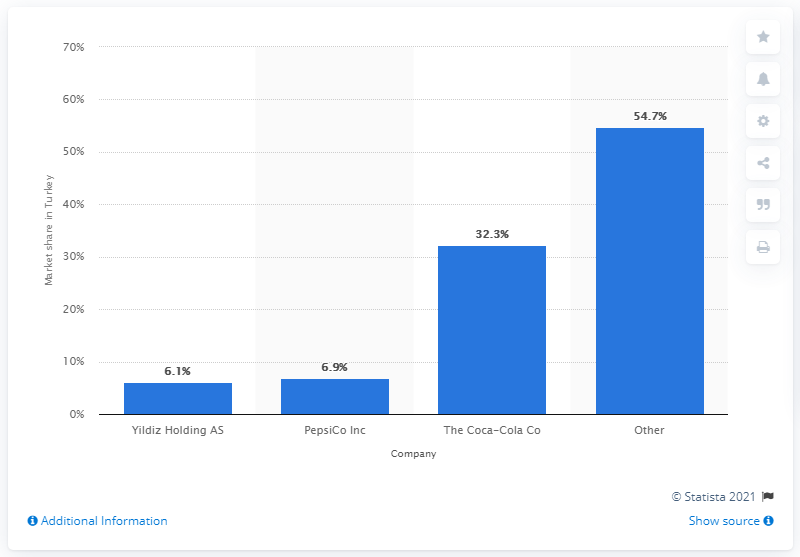Mention a couple of crucial points in this snapshot. In 2010, Coca Cola held a market share of 32.3% in Turkey. 